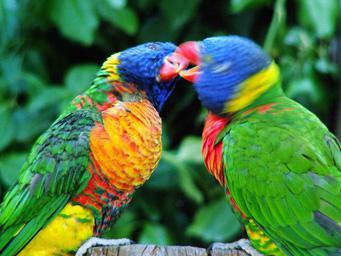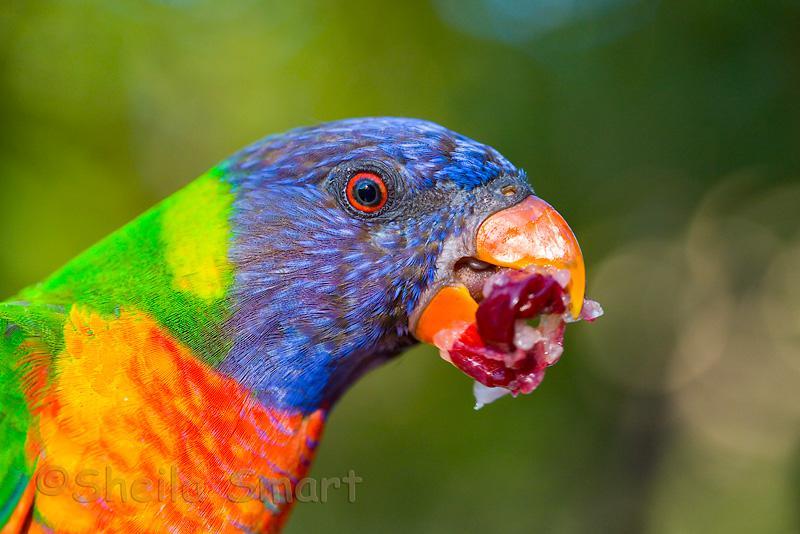The first image is the image on the left, the second image is the image on the right. For the images shown, is this caption "There is a total of 1 parrot perched on magenta colored flowers." true? Answer yes or no. No. The first image is the image on the left, the second image is the image on the right. For the images displayed, is the sentence "In the image to the left, the bird is eating from a flower." factually correct? Answer yes or no. No. 